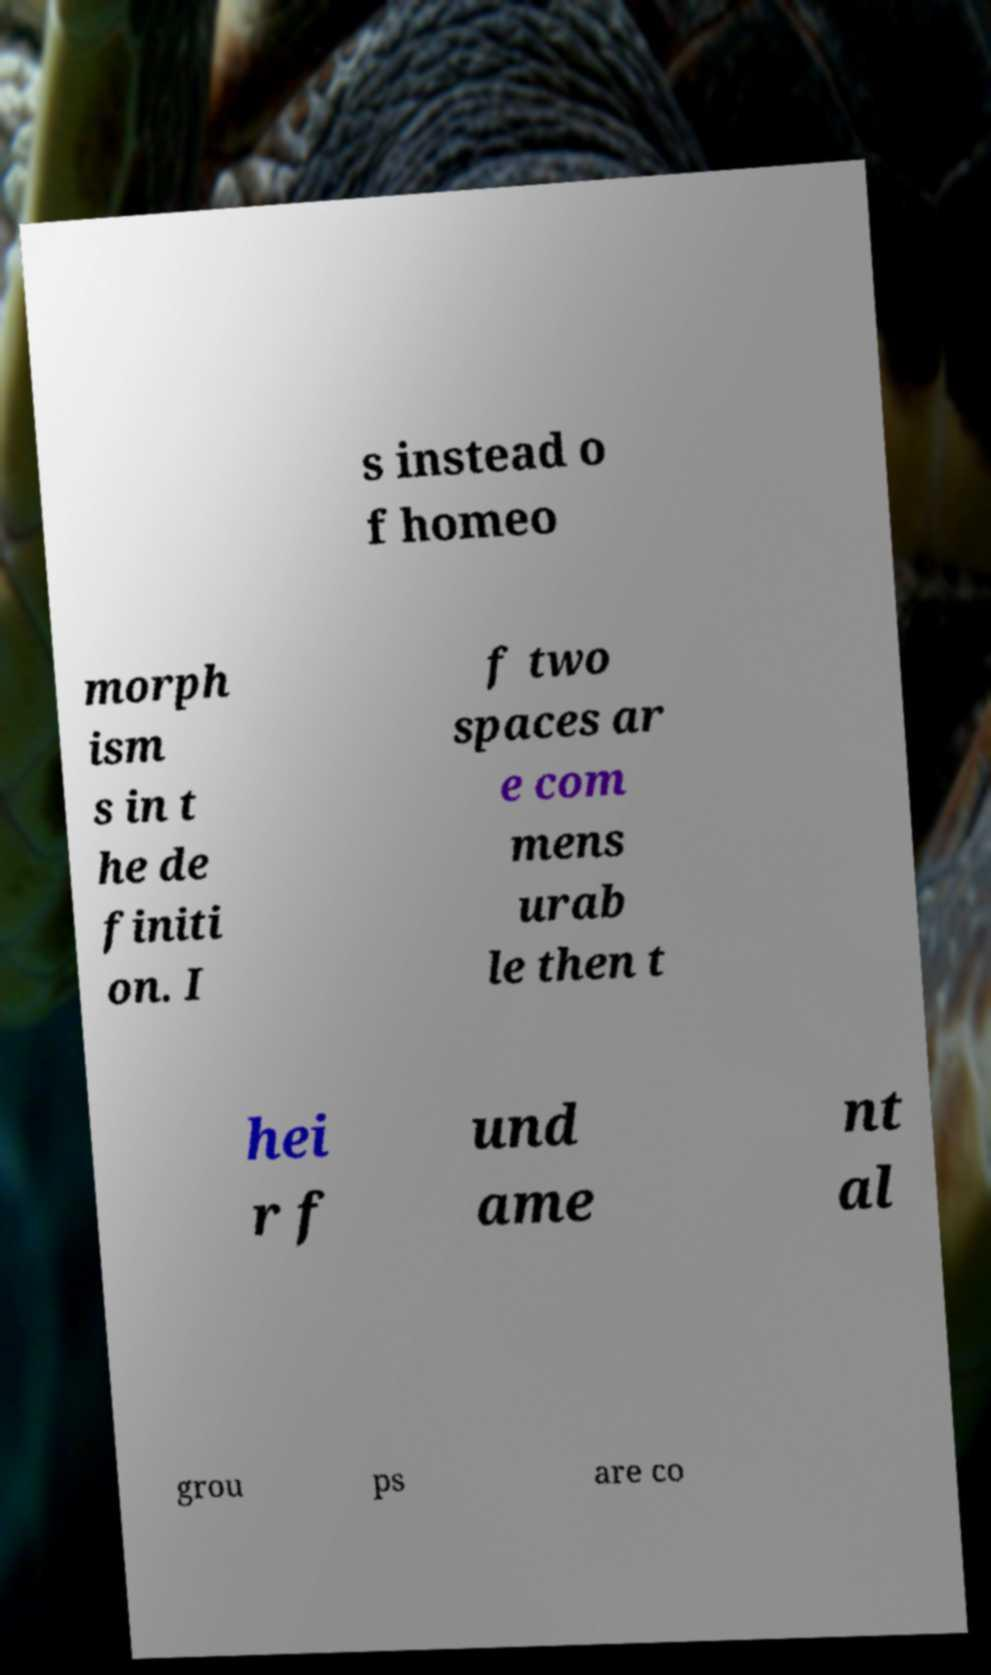What messages or text are displayed in this image? I need them in a readable, typed format. s instead o f homeo morph ism s in t he de finiti on. I f two spaces ar e com mens urab le then t hei r f und ame nt al grou ps are co 